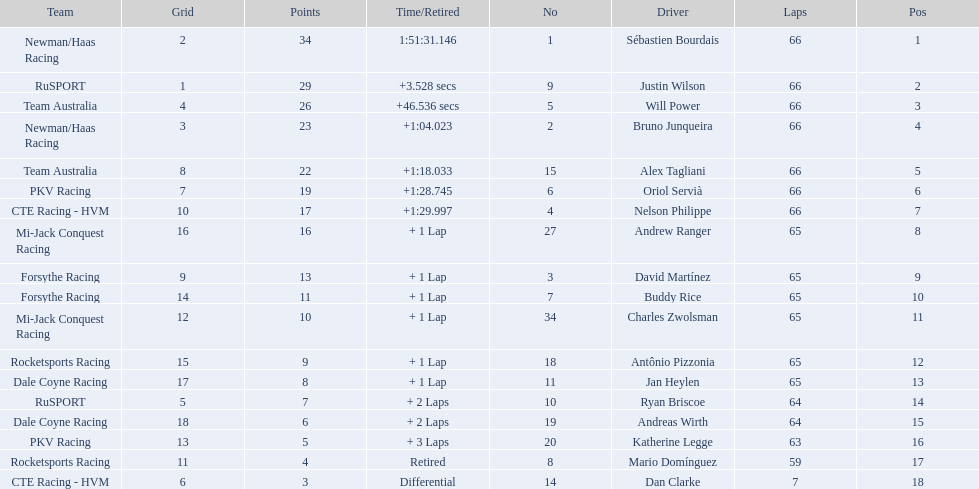What was the highest amount of points scored in the 2006 gran premio? 34. Who scored 34 points? Sébastien Bourdais. 